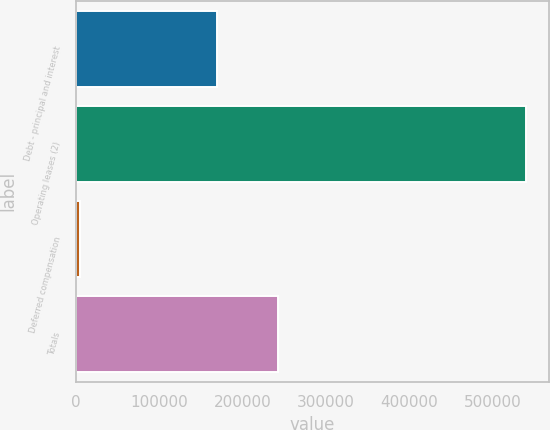Convert chart to OTSL. <chart><loc_0><loc_0><loc_500><loc_500><bar_chart><fcel>Debt - principal and interest<fcel>Operating leases (2)<fcel>Deferred compensation<fcel>Totals<nl><fcel>168900<fcel>539550<fcel>5185<fcel>241940<nl></chart> 